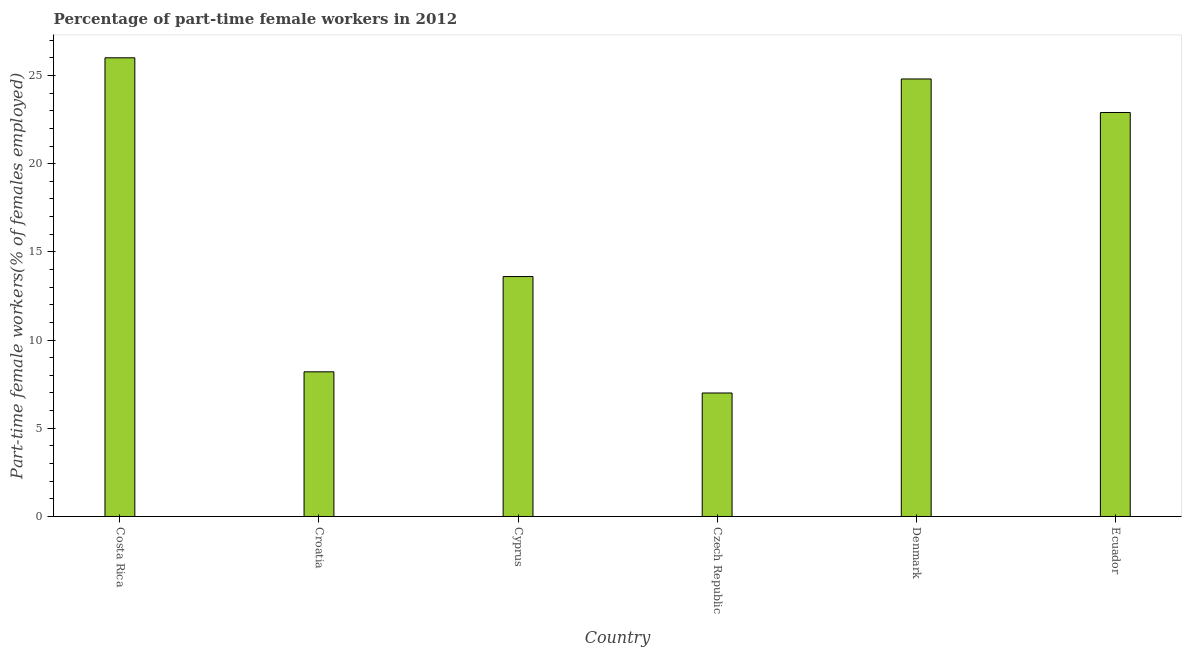Does the graph contain grids?
Give a very brief answer. No. What is the title of the graph?
Keep it short and to the point. Percentage of part-time female workers in 2012. What is the label or title of the Y-axis?
Give a very brief answer. Part-time female workers(% of females employed). What is the percentage of part-time female workers in Croatia?
Your answer should be very brief. 8.2. In which country was the percentage of part-time female workers maximum?
Your answer should be very brief. Costa Rica. In which country was the percentage of part-time female workers minimum?
Provide a short and direct response. Czech Republic. What is the sum of the percentage of part-time female workers?
Offer a terse response. 102.5. What is the average percentage of part-time female workers per country?
Your answer should be very brief. 17.08. What is the median percentage of part-time female workers?
Your response must be concise. 18.25. What is the ratio of the percentage of part-time female workers in Costa Rica to that in Croatia?
Keep it short and to the point. 3.17. What is the difference between the highest and the lowest percentage of part-time female workers?
Your response must be concise. 19. What is the difference between two consecutive major ticks on the Y-axis?
Your answer should be very brief. 5. Are the values on the major ticks of Y-axis written in scientific E-notation?
Your answer should be compact. No. What is the Part-time female workers(% of females employed) of Croatia?
Make the answer very short. 8.2. What is the Part-time female workers(% of females employed) in Cyprus?
Your answer should be compact. 13.6. What is the Part-time female workers(% of females employed) in Denmark?
Offer a terse response. 24.8. What is the Part-time female workers(% of females employed) in Ecuador?
Provide a short and direct response. 22.9. What is the difference between the Part-time female workers(% of females employed) in Costa Rica and Czech Republic?
Offer a very short reply. 19. What is the difference between the Part-time female workers(% of females employed) in Costa Rica and Ecuador?
Give a very brief answer. 3.1. What is the difference between the Part-time female workers(% of females employed) in Croatia and Cyprus?
Provide a succinct answer. -5.4. What is the difference between the Part-time female workers(% of females employed) in Croatia and Czech Republic?
Your answer should be very brief. 1.2. What is the difference between the Part-time female workers(% of females employed) in Croatia and Denmark?
Make the answer very short. -16.6. What is the difference between the Part-time female workers(% of females employed) in Croatia and Ecuador?
Provide a succinct answer. -14.7. What is the difference between the Part-time female workers(% of females employed) in Czech Republic and Denmark?
Offer a very short reply. -17.8. What is the difference between the Part-time female workers(% of females employed) in Czech Republic and Ecuador?
Offer a terse response. -15.9. What is the difference between the Part-time female workers(% of females employed) in Denmark and Ecuador?
Provide a succinct answer. 1.9. What is the ratio of the Part-time female workers(% of females employed) in Costa Rica to that in Croatia?
Ensure brevity in your answer.  3.17. What is the ratio of the Part-time female workers(% of females employed) in Costa Rica to that in Cyprus?
Your answer should be compact. 1.91. What is the ratio of the Part-time female workers(% of females employed) in Costa Rica to that in Czech Republic?
Keep it short and to the point. 3.71. What is the ratio of the Part-time female workers(% of females employed) in Costa Rica to that in Denmark?
Make the answer very short. 1.05. What is the ratio of the Part-time female workers(% of females employed) in Costa Rica to that in Ecuador?
Provide a succinct answer. 1.14. What is the ratio of the Part-time female workers(% of females employed) in Croatia to that in Cyprus?
Your answer should be very brief. 0.6. What is the ratio of the Part-time female workers(% of females employed) in Croatia to that in Czech Republic?
Your answer should be very brief. 1.17. What is the ratio of the Part-time female workers(% of females employed) in Croatia to that in Denmark?
Your answer should be compact. 0.33. What is the ratio of the Part-time female workers(% of females employed) in Croatia to that in Ecuador?
Provide a short and direct response. 0.36. What is the ratio of the Part-time female workers(% of females employed) in Cyprus to that in Czech Republic?
Offer a very short reply. 1.94. What is the ratio of the Part-time female workers(% of females employed) in Cyprus to that in Denmark?
Provide a short and direct response. 0.55. What is the ratio of the Part-time female workers(% of females employed) in Cyprus to that in Ecuador?
Offer a terse response. 0.59. What is the ratio of the Part-time female workers(% of females employed) in Czech Republic to that in Denmark?
Your answer should be very brief. 0.28. What is the ratio of the Part-time female workers(% of females employed) in Czech Republic to that in Ecuador?
Your response must be concise. 0.31. What is the ratio of the Part-time female workers(% of females employed) in Denmark to that in Ecuador?
Ensure brevity in your answer.  1.08. 